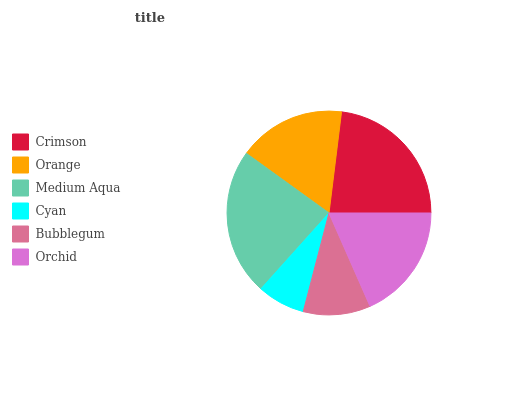Is Cyan the minimum?
Answer yes or no. Yes. Is Medium Aqua the maximum?
Answer yes or no. Yes. Is Orange the minimum?
Answer yes or no. No. Is Orange the maximum?
Answer yes or no. No. Is Crimson greater than Orange?
Answer yes or no. Yes. Is Orange less than Crimson?
Answer yes or no. Yes. Is Orange greater than Crimson?
Answer yes or no. No. Is Crimson less than Orange?
Answer yes or no. No. Is Orchid the high median?
Answer yes or no. Yes. Is Orange the low median?
Answer yes or no. Yes. Is Cyan the high median?
Answer yes or no. No. Is Crimson the low median?
Answer yes or no. No. 